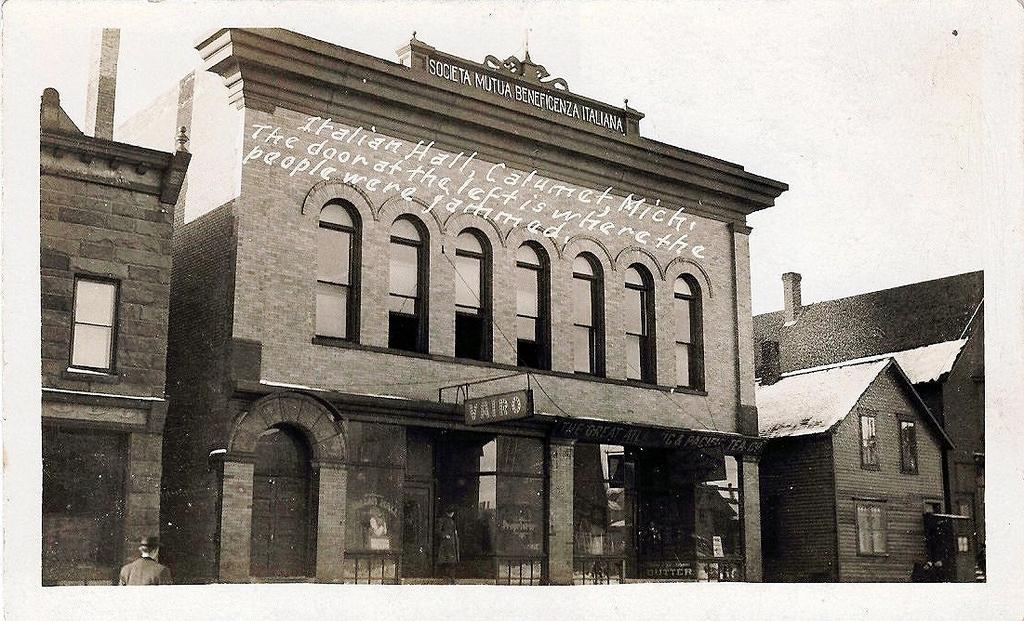What is the main structure visible in the image? There is a building in the image. Can you describe any additional details about the building? There is some text on the top of the building. How many children are participating in the kissing contest on the roof of the building? There is no mention of a kissing contest or children in the image; it only shows a building with text on the top. 